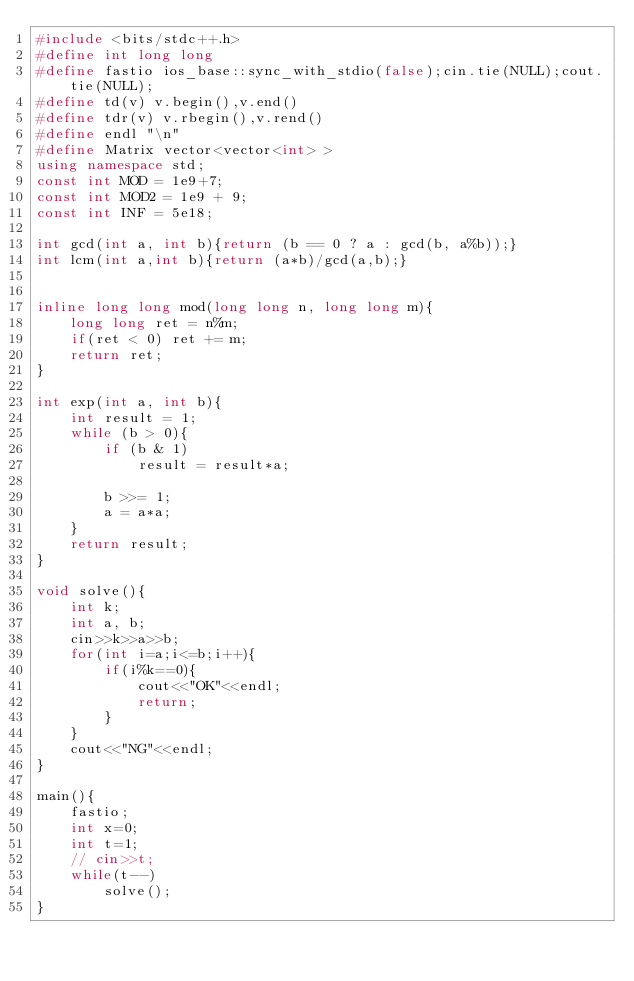<code> <loc_0><loc_0><loc_500><loc_500><_C++_>#include <bits/stdc++.h>
#define int long long
#define fastio ios_base::sync_with_stdio(false);cin.tie(NULL);cout.tie(NULL);
#define td(v) v.begin(),v.end()
#define tdr(v) v.rbegin(),v.rend()
#define endl "\n"
#define Matrix vector<vector<int> >
using namespace std;
const int MOD = 1e9+7;
const int MOD2 = 1e9 + 9;
const int INF = 5e18;
 
int gcd(int a, int b){return (b == 0 ? a : gcd(b, a%b));}
int lcm(int a,int b){return (a*b)/gcd(a,b);}
 
 
inline long long mod(long long n, long long m){
    long long ret = n%m;
    if(ret < 0) ret += m;
    return ret;
}
 
int exp(int a, int b){
    int result = 1;
    while (b > 0){
        if (b & 1)
            result = result*a;
 
        b >>= 1;
        a = a*a;
    }
    return result;
}

void solve(){
    int k;
    int a, b;
    cin>>k>>a>>b;
    for(int i=a;i<=b;i++){
        if(i%k==0){
            cout<<"OK"<<endl;
            return;
        }
    }
    cout<<"NG"<<endl;
}
 
main(){
    fastio; 
    int x=0;
    int t=1;
    // cin>>t;
    while(t--)
        solve();
}</code> 